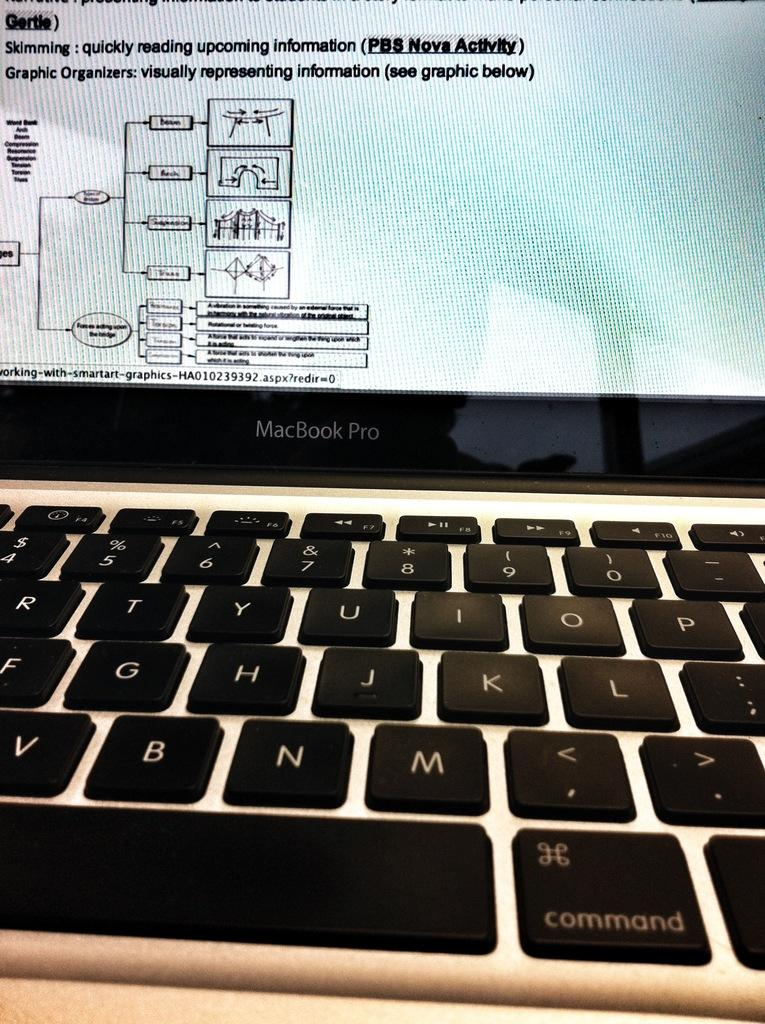<image>
Summarize the visual content of the image. A MacBook Pro monitor displays definitions of skimming and graphic organizers. 